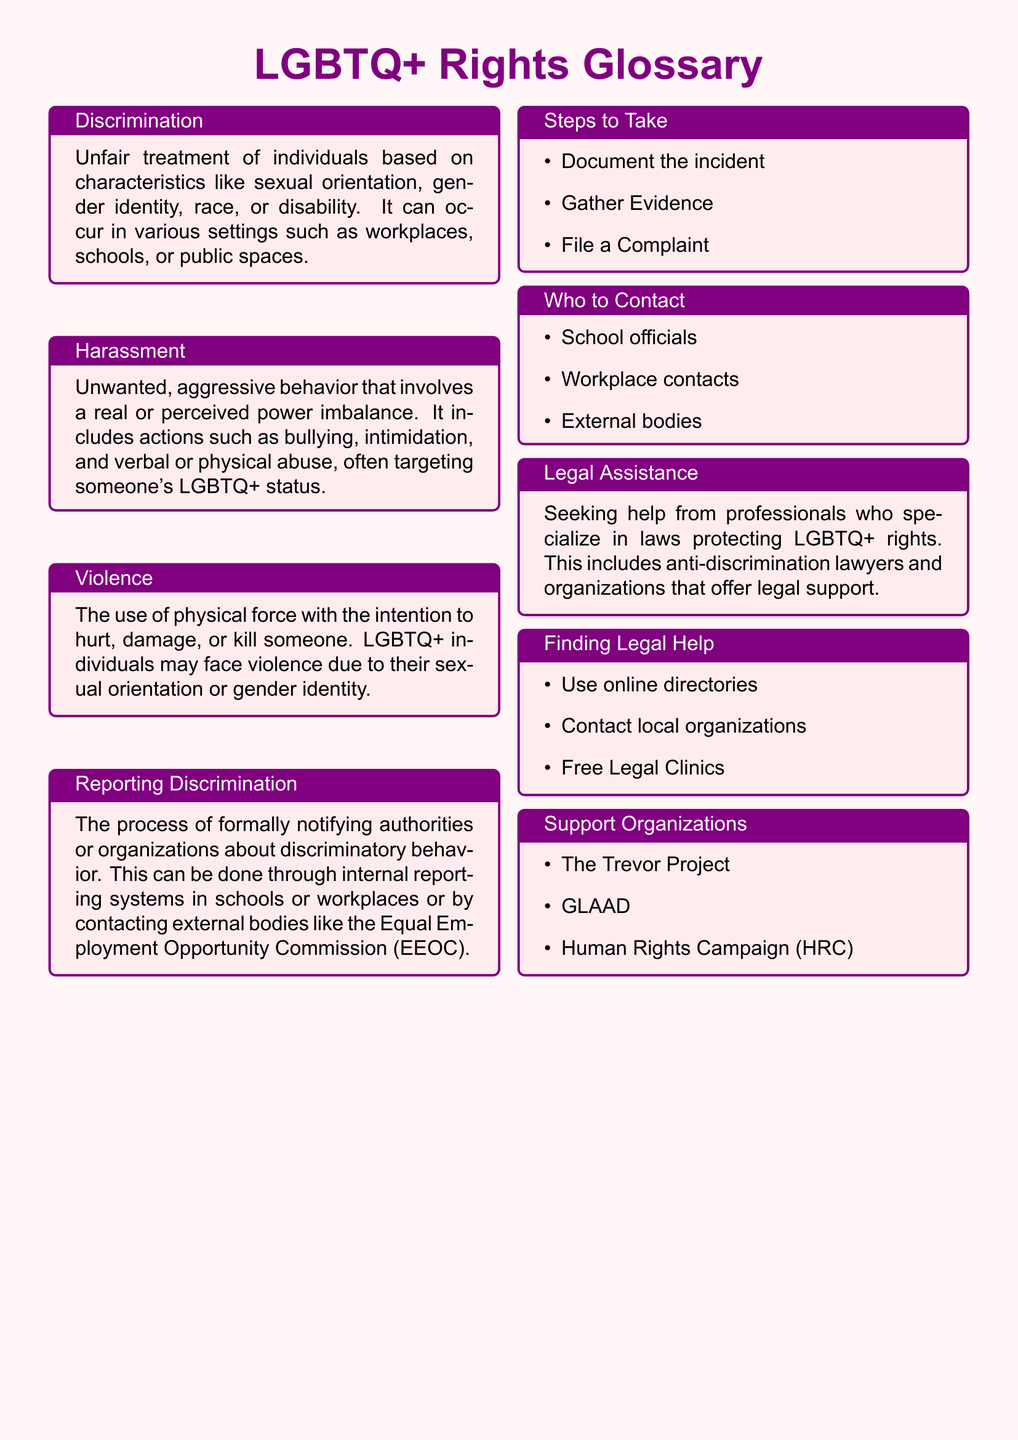What is the definition of discrimination? Discrimination is defined in the document as unfair treatment of individuals based on characteristics like sexual orientation, gender identity, race, or disability.
Answer: unfair treatment Who can you report discrimination to? The document lists school officials, workplace contacts, and external bodies as whom to contact for reporting discrimination.
Answer: school officials, workplace contacts, external bodies What is the first step to take when reporting discrimination? The first step mentioned in the document for reporting discrimination is to document the incident.
Answer: document the incident Which organization is specifically mentioned as a support organization? The Trevor Project is a support organization that is mentioned in the document.
Answer: The Trevor Project What type of professionals specialize in LGBTQ+ rights laws? Anti-discrimination lawyers are mentioned in the document as professionals who specialize in laws protecting LGBTQ+ rights.
Answer: Anti-discrimination lawyers How can you find legal help according to the document? The document states to use online directories, contact local organizations, and visit free legal clinics as ways to find legal help.
Answer: use online directories, contact local organizations, free legal clinics What type of behavior does harassment include? Harassment includes unwanted, aggressive behavior such as bullying, intimidation, and verbal or physical abuse.
Answer: bullying, intimidation, verbal or physical abuse What should you gather as part of the steps to take? The document advises gathering evidence as one of the steps to take when reporting discrimination.
Answer: gather evidence 